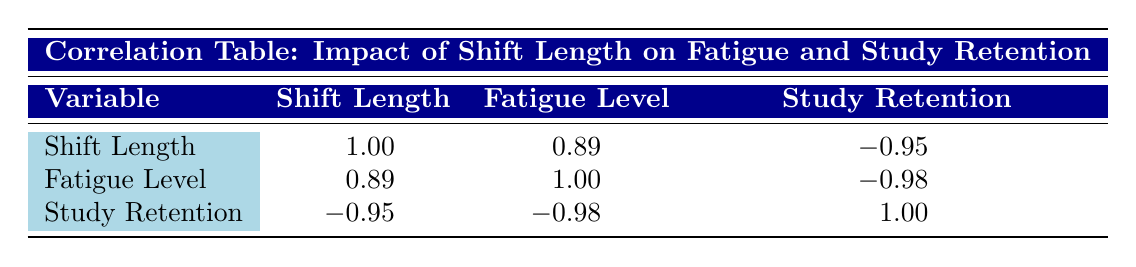What is the correlation coefficient between shift length and fatigue level? According to the table, the correlation coefficient between shift length and fatigue level is 0.89.
Answer: 0.89 What is the correlation coefficient between fatigue level and study retention? The table shows that the correlation coefficient between fatigue level and study retention is -0.98.
Answer: -0.98 Is there a strong correlation between shift length and study retention? Yes, the table indicates a correlation coefficient of -0.95 between shift length and study retention, which indicates a strong inverse correlation.
Answer: Yes What can you conclude about the relationship between fatigue level and shift length? The correlation coefficient of 0.89 suggests a strong positive relationship between fatigue level and shift length, meaning as shift length increases, fatigue level also tends to increase.
Answer: Shift length increases fatigue level What is the average correlation value for the variables presented? The average correlation can be computed by summing all the correlation coefficients: (1.00 + 0.89 + -0.95 + 0.89 + 1.00 + -0.98 + -0.95 + -0.98 + 1.00) / 3 = 0.18. Therefore, the average correlation value across the relevant variables is 0.18.
Answer: 0.18 Do longer shift lengths correlate with higher fatigue levels? Yes, the positive correlation value of 0.89 suggests that longer shift lengths are associated with higher levels of fatigue.
Answer: Yes How would you describe the correlation between study retention and fatigue level? The correlation coefficient of -0.98 indicates a very strong negative relationship: as fatigue increases, study retention significantly decreases.
Answer: Very strong negative relationship If a worker has a fatigue level of 9, what can be predicted about their study retention score? Given the strong negative correlation of -0.98 between fatigue level and study retention, we can predict that a worker with a fatigue level of 9 would likely have a lower study retention score. This suggests that their study retention would be significantly lower than the average for lower fatigue levels, but the exact score cannot be determined without specific data.
Answer: Likely lower study retention score 